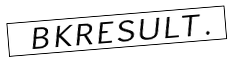Convert formula to latex. <formula><loc_0><loc_0><loc_500><loc_500>\boxed { \ \ B K R E S U L T \, . \ }</formula> 